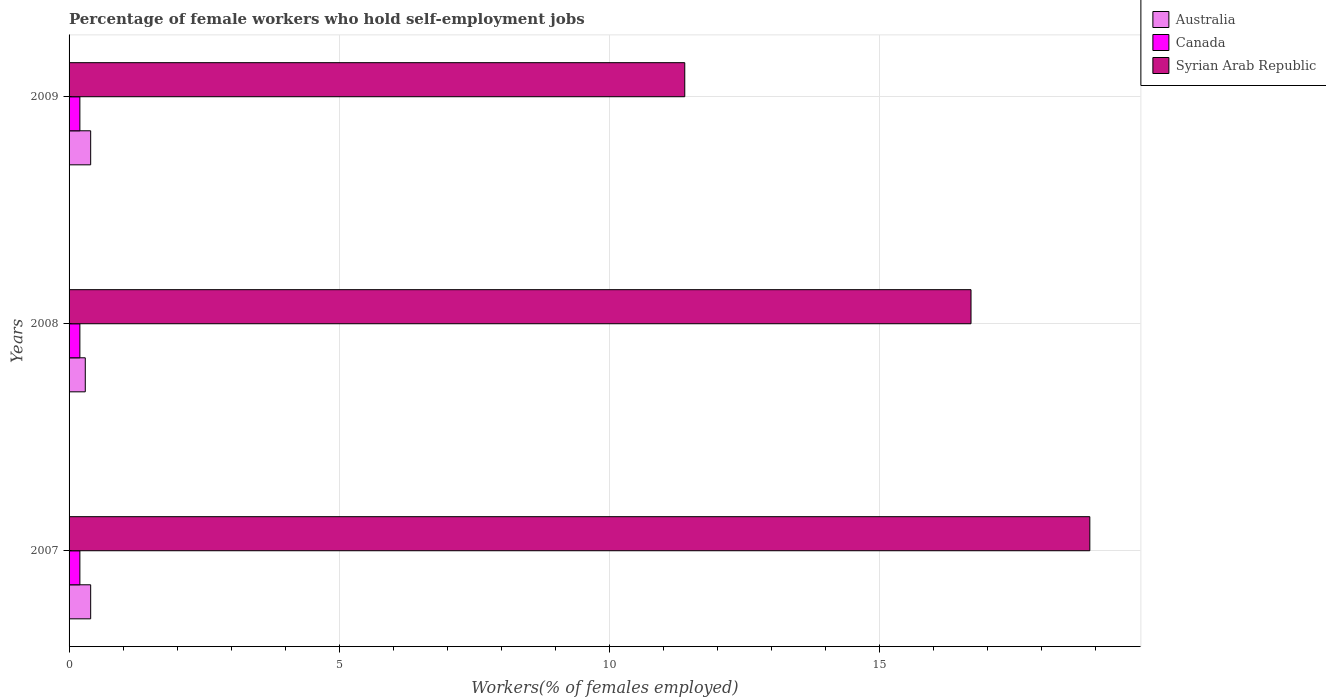How many different coloured bars are there?
Provide a short and direct response. 3. How many groups of bars are there?
Make the answer very short. 3. Are the number of bars on each tick of the Y-axis equal?
Your answer should be compact. Yes. How many bars are there on the 1st tick from the top?
Your answer should be very brief. 3. What is the label of the 2nd group of bars from the top?
Give a very brief answer. 2008. What is the percentage of self-employed female workers in Syrian Arab Republic in 2007?
Your answer should be very brief. 18.9. Across all years, what is the maximum percentage of self-employed female workers in Syrian Arab Republic?
Your answer should be very brief. 18.9. Across all years, what is the minimum percentage of self-employed female workers in Syrian Arab Republic?
Make the answer very short. 11.4. In which year was the percentage of self-employed female workers in Canada minimum?
Offer a terse response. 2007. What is the total percentage of self-employed female workers in Australia in the graph?
Make the answer very short. 1.1. What is the difference between the percentage of self-employed female workers in Australia in 2008 and that in 2009?
Ensure brevity in your answer.  -0.1. What is the difference between the percentage of self-employed female workers in Syrian Arab Republic in 2009 and the percentage of self-employed female workers in Australia in 2008?
Your answer should be very brief. 11.1. What is the average percentage of self-employed female workers in Canada per year?
Offer a very short reply. 0.2. In the year 2008, what is the difference between the percentage of self-employed female workers in Australia and percentage of self-employed female workers in Canada?
Your answer should be compact. 0.1. What is the ratio of the percentage of self-employed female workers in Syrian Arab Republic in 2008 to that in 2009?
Offer a terse response. 1.46. Is the percentage of self-employed female workers in Canada in 2007 less than that in 2008?
Give a very brief answer. No. Is the difference between the percentage of self-employed female workers in Australia in 2008 and 2009 greater than the difference between the percentage of self-employed female workers in Canada in 2008 and 2009?
Give a very brief answer. No. What is the difference between the highest and the second highest percentage of self-employed female workers in Australia?
Give a very brief answer. 0. What is the difference between the highest and the lowest percentage of self-employed female workers in Australia?
Provide a short and direct response. 0.1. In how many years, is the percentage of self-employed female workers in Syrian Arab Republic greater than the average percentage of self-employed female workers in Syrian Arab Republic taken over all years?
Ensure brevity in your answer.  2. What does the 2nd bar from the top in 2007 represents?
Ensure brevity in your answer.  Canada. What does the 3rd bar from the bottom in 2009 represents?
Provide a short and direct response. Syrian Arab Republic. How many bars are there?
Your answer should be compact. 9. What is the difference between two consecutive major ticks on the X-axis?
Provide a short and direct response. 5. Are the values on the major ticks of X-axis written in scientific E-notation?
Your answer should be very brief. No. Does the graph contain grids?
Make the answer very short. Yes. Where does the legend appear in the graph?
Provide a short and direct response. Top right. How are the legend labels stacked?
Offer a terse response. Vertical. What is the title of the graph?
Ensure brevity in your answer.  Percentage of female workers who hold self-employment jobs. Does "Botswana" appear as one of the legend labels in the graph?
Give a very brief answer. No. What is the label or title of the X-axis?
Provide a short and direct response. Workers(% of females employed). What is the label or title of the Y-axis?
Provide a short and direct response. Years. What is the Workers(% of females employed) of Australia in 2007?
Ensure brevity in your answer.  0.4. What is the Workers(% of females employed) in Canada in 2007?
Offer a very short reply. 0.2. What is the Workers(% of females employed) in Syrian Arab Republic in 2007?
Your answer should be very brief. 18.9. What is the Workers(% of females employed) of Australia in 2008?
Your answer should be compact. 0.3. What is the Workers(% of females employed) of Canada in 2008?
Give a very brief answer. 0.2. What is the Workers(% of females employed) of Syrian Arab Republic in 2008?
Make the answer very short. 16.7. What is the Workers(% of females employed) of Australia in 2009?
Provide a succinct answer. 0.4. What is the Workers(% of females employed) in Canada in 2009?
Provide a short and direct response. 0.2. What is the Workers(% of females employed) of Syrian Arab Republic in 2009?
Make the answer very short. 11.4. Across all years, what is the maximum Workers(% of females employed) in Australia?
Offer a terse response. 0.4. Across all years, what is the maximum Workers(% of females employed) in Canada?
Your answer should be very brief. 0.2. Across all years, what is the maximum Workers(% of females employed) in Syrian Arab Republic?
Your answer should be compact. 18.9. Across all years, what is the minimum Workers(% of females employed) of Australia?
Offer a terse response. 0.3. Across all years, what is the minimum Workers(% of females employed) of Canada?
Offer a very short reply. 0.2. Across all years, what is the minimum Workers(% of females employed) in Syrian Arab Republic?
Provide a short and direct response. 11.4. What is the total Workers(% of females employed) in Syrian Arab Republic in the graph?
Give a very brief answer. 47. What is the difference between the Workers(% of females employed) of Australia in 2007 and that in 2008?
Offer a very short reply. 0.1. What is the difference between the Workers(% of females employed) in Canada in 2007 and that in 2008?
Keep it short and to the point. 0. What is the difference between the Workers(% of females employed) of Canada in 2007 and that in 2009?
Your answer should be very brief. 0. What is the difference between the Workers(% of females employed) of Syrian Arab Republic in 2007 and that in 2009?
Your answer should be very brief. 7.5. What is the difference between the Workers(% of females employed) in Syrian Arab Republic in 2008 and that in 2009?
Provide a short and direct response. 5.3. What is the difference between the Workers(% of females employed) of Australia in 2007 and the Workers(% of females employed) of Canada in 2008?
Keep it short and to the point. 0.2. What is the difference between the Workers(% of females employed) of Australia in 2007 and the Workers(% of females employed) of Syrian Arab Republic in 2008?
Keep it short and to the point. -16.3. What is the difference between the Workers(% of females employed) in Canada in 2007 and the Workers(% of females employed) in Syrian Arab Republic in 2008?
Ensure brevity in your answer.  -16.5. What is the difference between the Workers(% of females employed) in Australia in 2007 and the Workers(% of females employed) in Canada in 2009?
Make the answer very short. 0.2. What is the difference between the Workers(% of females employed) of Australia in 2007 and the Workers(% of females employed) of Syrian Arab Republic in 2009?
Offer a terse response. -11. What is the difference between the Workers(% of females employed) of Canada in 2007 and the Workers(% of females employed) of Syrian Arab Republic in 2009?
Your answer should be very brief. -11.2. What is the difference between the Workers(% of females employed) of Canada in 2008 and the Workers(% of females employed) of Syrian Arab Republic in 2009?
Give a very brief answer. -11.2. What is the average Workers(% of females employed) of Australia per year?
Provide a succinct answer. 0.37. What is the average Workers(% of females employed) in Canada per year?
Keep it short and to the point. 0.2. What is the average Workers(% of females employed) in Syrian Arab Republic per year?
Make the answer very short. 15.67. In the year 2007, what is the difference between the Workers(% of females employed) of Australia and Workers(% of females employed) of Syrian Arab Republic?
Ensure brevity in your answer.  -18.5. In the year 2007, what is the difference between the Workers(% of females employed) in Canada and Workers(% of females employed) in Syrian Arab Republic?
Your response must be concise. -18.7. In the year 2008, what is the difference between the Workers(% of females employed) of Australia and Workers(% of females employed) of Syrian Arab Republic?
Your response must be concise. -16.4. In the year 2008, what is the difference between the Workers(% of females employed) in Canada and Workers(% of females employed) in Syrian Arab Republic?
Offer a terse response. -16.5. In the year 2009, what is the difference between the Workers(% of females employed) of Australia and Workers(% of females employed) of Canada?
Offer a very short reply. 0.2. What is the ratio of the Workers(% of females employed) of Canada in 2007 to that in 2008?
Your response must be concise. 1. What is the ratio of the Workers(% of females employed) in Syrian Arab Republic in 2007 to that in 2008?
Give a very brief answer. 1.13. What is the ratio of the Workers(% of females employed) in Australia in 2007 to that in 2009?
Your response must be concise. 1. What is the ratio of the Workers(% of females employed) of Syrian Arab Republic in 2007 to that in 2009?
Make the answer very short. 1.66. What is the ratio of the Workers(% of females employed) of Australia in 2008 to that in 2009?
Your answer should be very brief. 0.75. What is the ratio of the Workers(% of females employed) of Syrian Arab Republic in 2008 to that in 2009?
Keep it short and to the point. 1.46. What is the difference between the highest and the second highest Workers(% of females employed) in Canada?
Your response must be concise. 0. What is the difference between the highest and the second highest Workers(% of females employed) of Syrian Arab Republic?
Your response must be concise. 2.2. What is the difference between the highest and the lowest Workers(% of females employed) of Canada?
Your answer should be very brief. 0. 